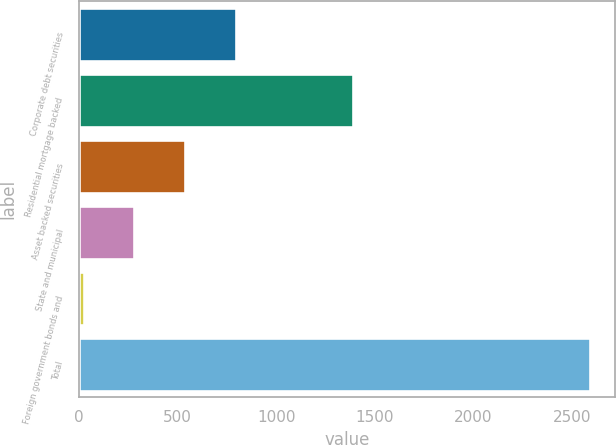Convert chart to OTSL. <chart><loc_0><loc_0><loc_500><loc_500><bar_chart><fcel>Corporate debt securities<fcel>Residential mortgage backed<fcel>Asset backed securities<fcel>State and municipal<fcel>Foreign government bonds and<fcel>Total<nl><fcel>795<fcel>1387<fcel>539<fcel>283<fcel>27<fcel>2587<nl></chart> 